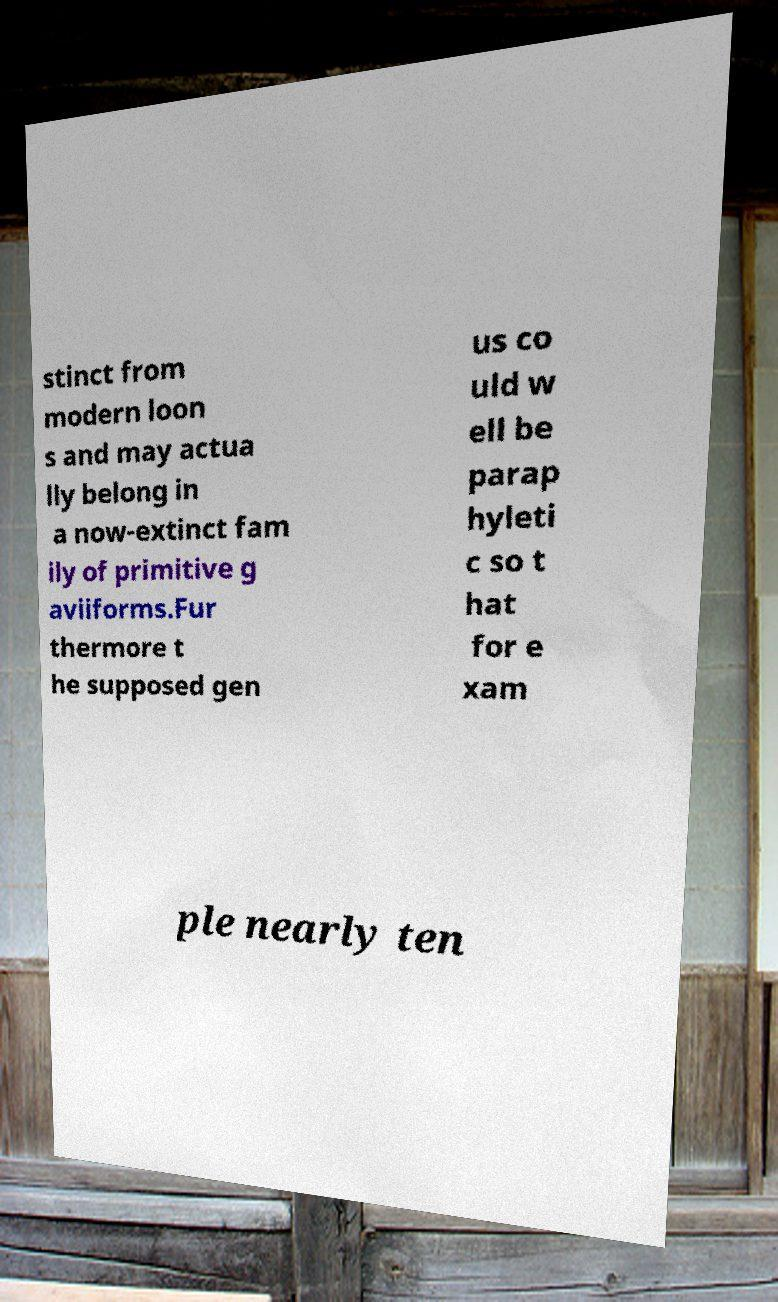Can you read and provide the text displayed in the image?This photo seems to have some interesting text. Can you extract and type it out for me? stinct from modern loon s and may actua lly belong in a now-extinct fam ily of primitive g aviiforms.Fur thermore t he supposed gen us co uld w ell be parap hyleti c so t hat for e xam ple nearly ten 